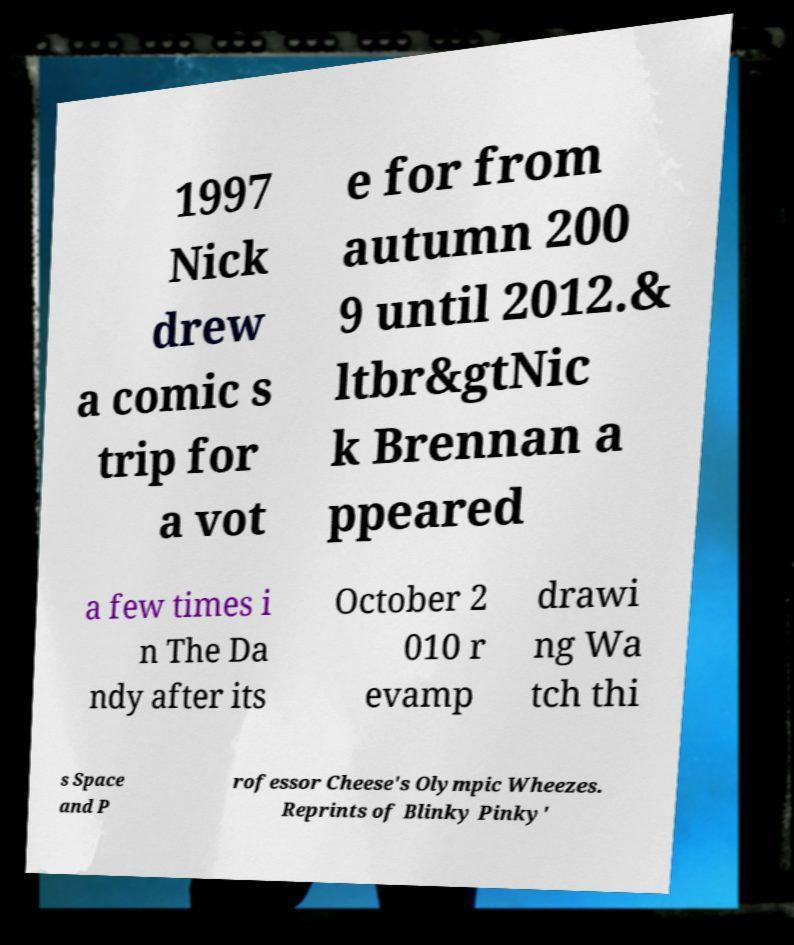I need the written content from this picture converted into text. Can you do that? 1997 Nick drew a comic s trip for a vot e for from autumn 200 9 until 2012.& ltbr&gtNic k Brennan a ppeared a few times i n The Da ndy after its October 2 010 r evamp drawi ng Wa tch thi s Space and P rofessor Cheese's Olympic Wheezes. Reprints of Blinky Pinky' 